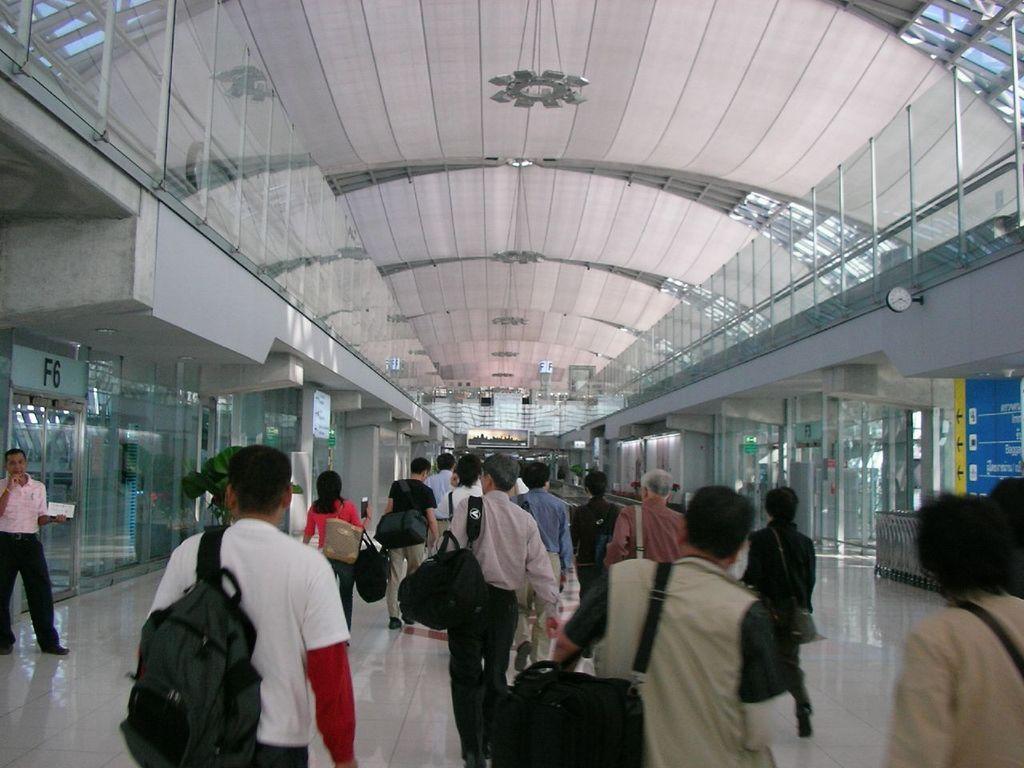Describe this image in one or two sentences. In the foreground, I can see a group of people on the floor and boards. In the background, I can see pillars, glass windows, doors, fence and a rooftop. This image taken, maybe on the platform. 